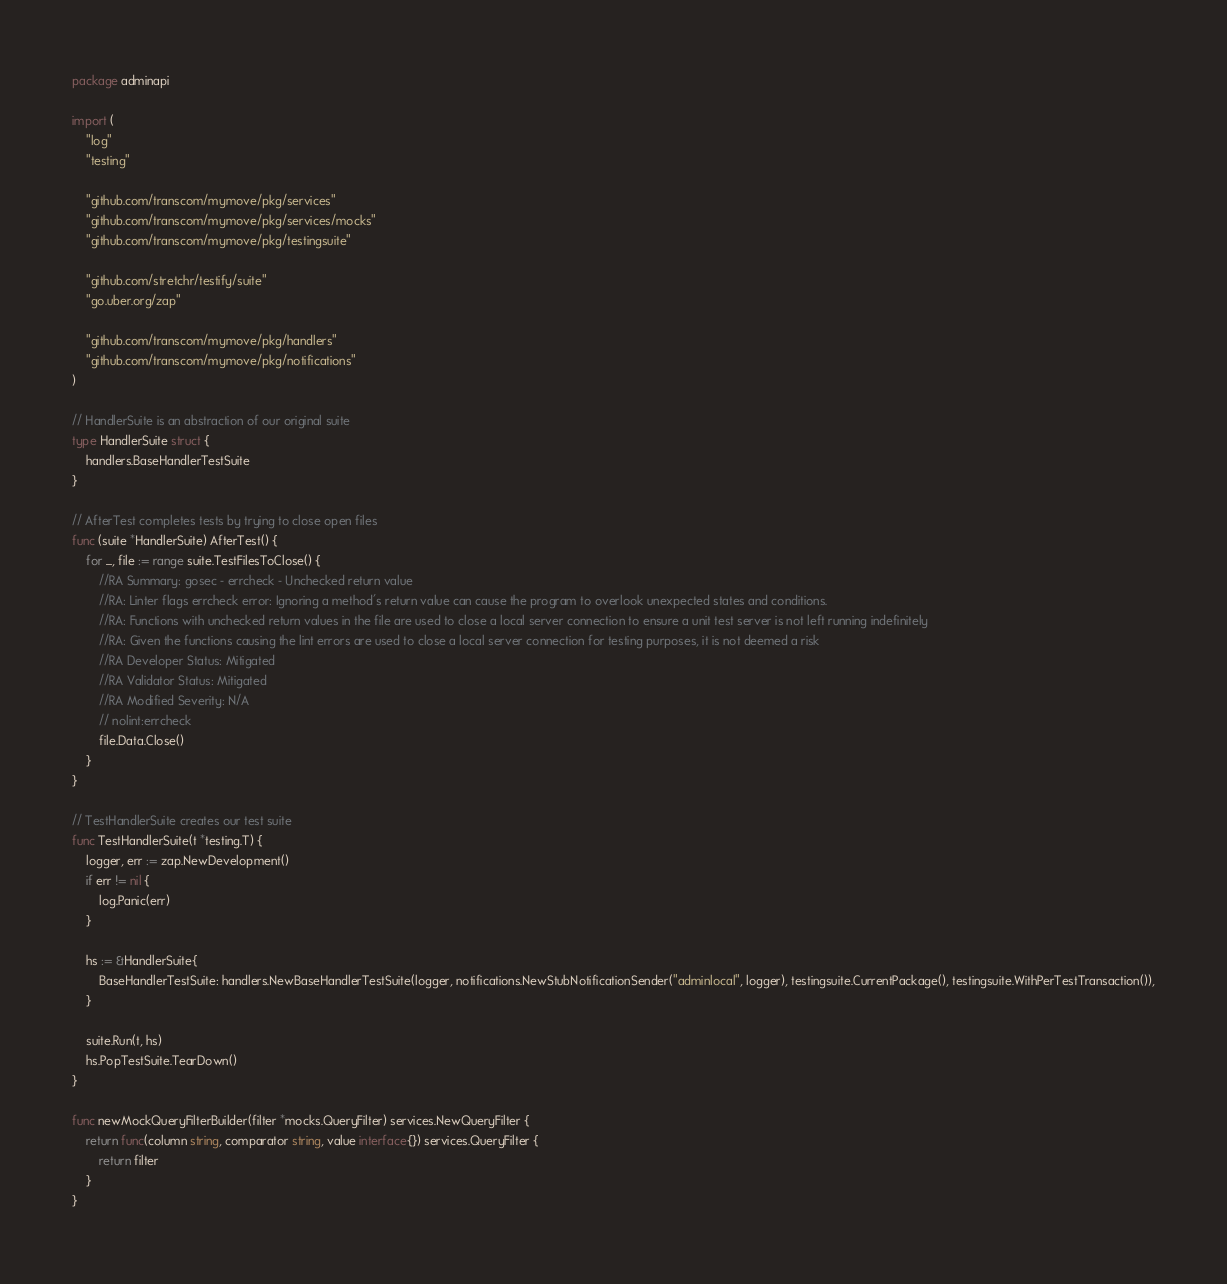Convert code to text. <code><loc_0><loc_0><loc_500><loc_500><_Go_>package adminapi

import (
	"log"
	"testing"

	"github.com/transcom/mymove/pkg/services"
	"github.com/transcom/mymove/pkg/services/mocks"
	"github.com/transcom/mymove/pkg/testingsuite"

	"github.com/stretchr/testify/suite"
	"go.uber.org/zap"

	"github.com/transcom/mymove/pkg/handlers"
	"github.com/transcom/mymove/pkg/notifications"
)

// HandlerSuite is an abstraction of our original suite
type HandlerSuite struct {
	handlers.BaseHandlerTestSuite
}

// AfterTest completes tests by trying to close open files
func (suite *HandlerSuite) AfterTest() {
	for _, file := range suite.TestFilesToClose() {
		//RA Summary: gosec - errcheck - Unchecked return value
		//RA: Linter flags errcheck error: Ignoring a method's return value can cause the program to overlook unexpected states and conditions.
		//RA: Functions with unchecked return values in the file are used to close a local server connection to ensure a unit test server is not left running indefinitely
		//RA: Given the functions causing the lint errors are used to close a local server connection for testing purposes, it is not deemed a risk
		//RA Developer Status: Mitigated
		//RA Validator Status: Mitigated
		//RA Modified Severity: N/A
		// nolint:errcheck
		file.Data.Close()
	}
}

// TestHandlerSuite creates our test suite
func TestHandlerSuite(t *testing.T) {
	logger, err := zap.NewDevelopment()
	if err != nil {
		log.Panic(err)
	}

	hs := &HandlerSuite{
		BaseHandlerTestSuite: handlers.NewBaseHandlerTestSuite(logger, notifications.NewStubNotificationSender("adminlocal", logger), testingsuite.CurrentPackage(), testingsuite.WithPerTestTransaction()),
	}

	suite.Run(t, hs)
	hs.PopTestSuite.TearDown()
}

func newMockQueryFilterBuilder(filter *mocks.QueryFilter) services.NewQueryFilter {
	return func(column string, comparator string, value interface{}) services.QueryFilter {
		return filter
	}
}
</code> 